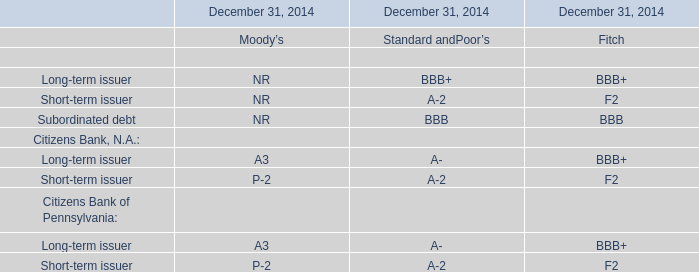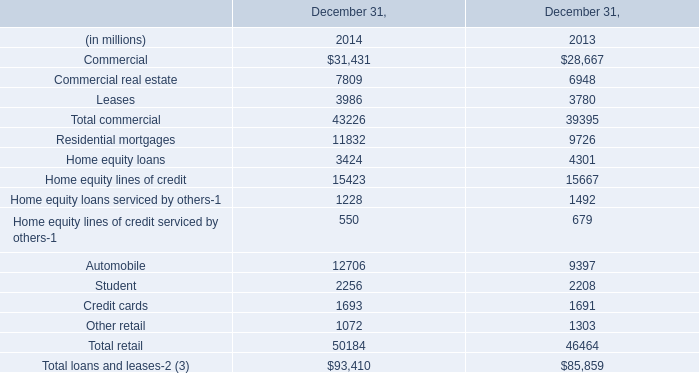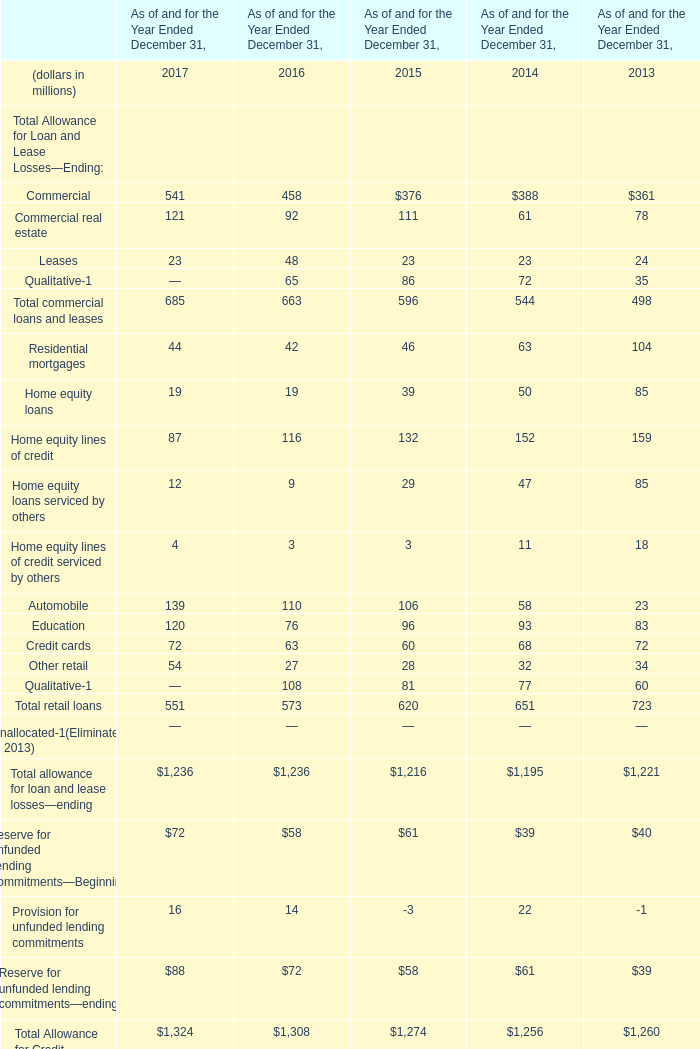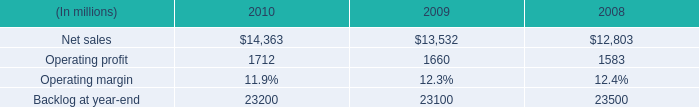what is the highest total amount of retail loans? (in million) 
Answer: 723. 